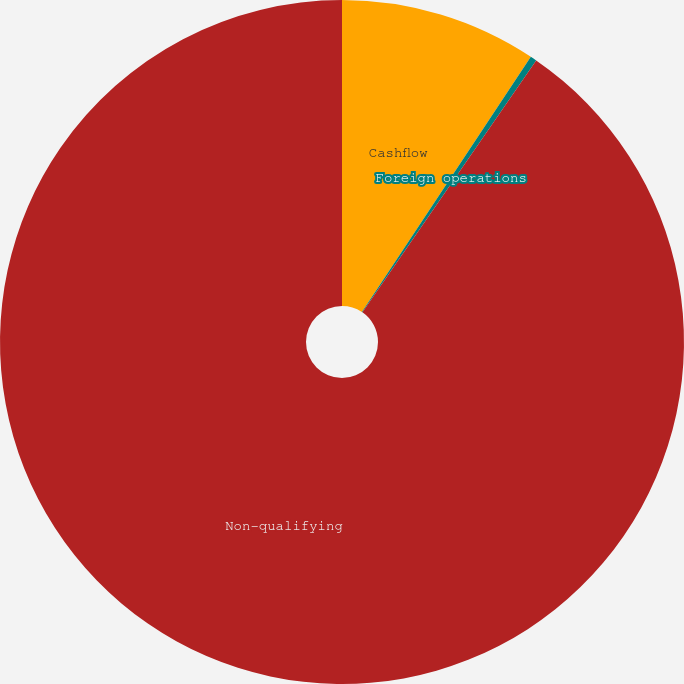Convert chart to OTSL. <chart><loc_0><loc_0><loc_500><loc_500><pie_chart><fcel>Cashflow<fcel>Foreign operations<fcel>Non-qualifying<nl><fcel>9.31%<fcel>0.3%<fcel>90.39%<nl></chart> 